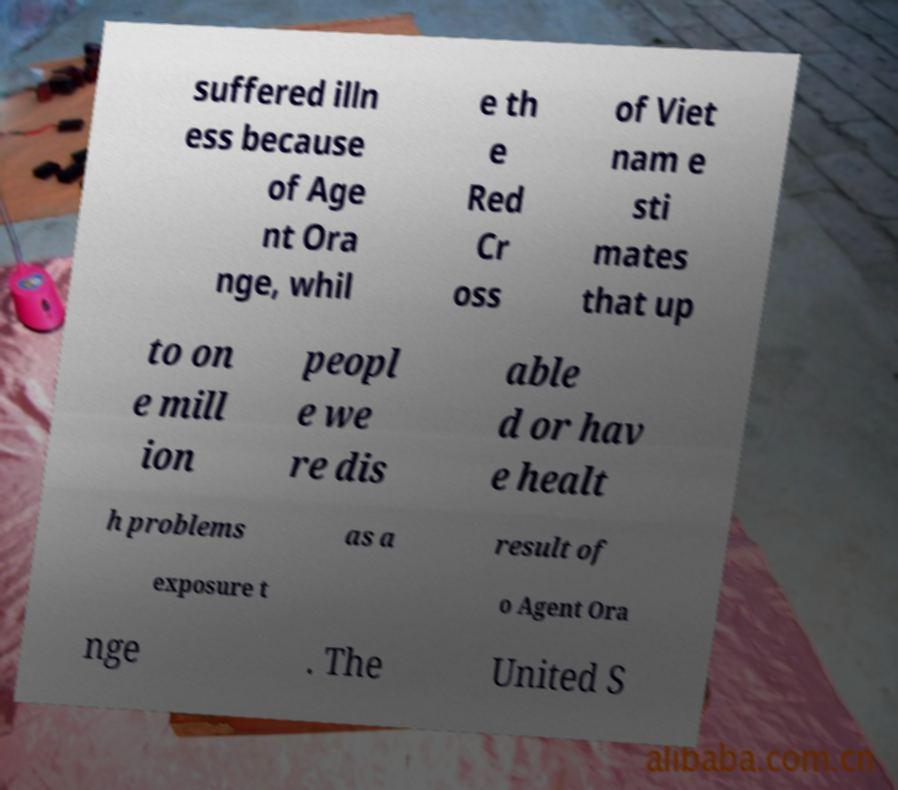Could you assist in decoding the text presented in this image and type it out clearly? suffered illn ess because of Age nt Ora nge, whil e th e Red Cr oss of Viet nam e sti mates that up to on e mill ion peopl e we re dis able d or hav e healt h problems as a result of exposure t o Agent Ora nge . The United S 